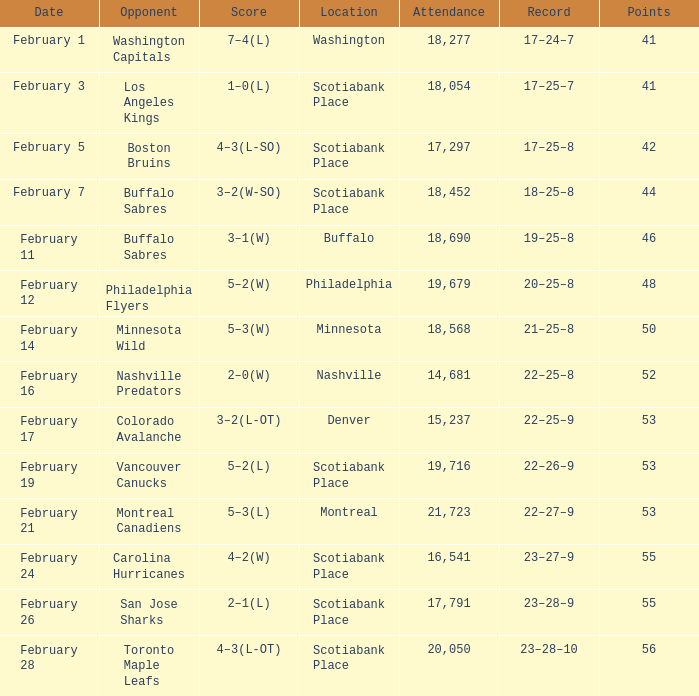What average game was held on february 24 and has an attendance smaller than 16,541? None. 